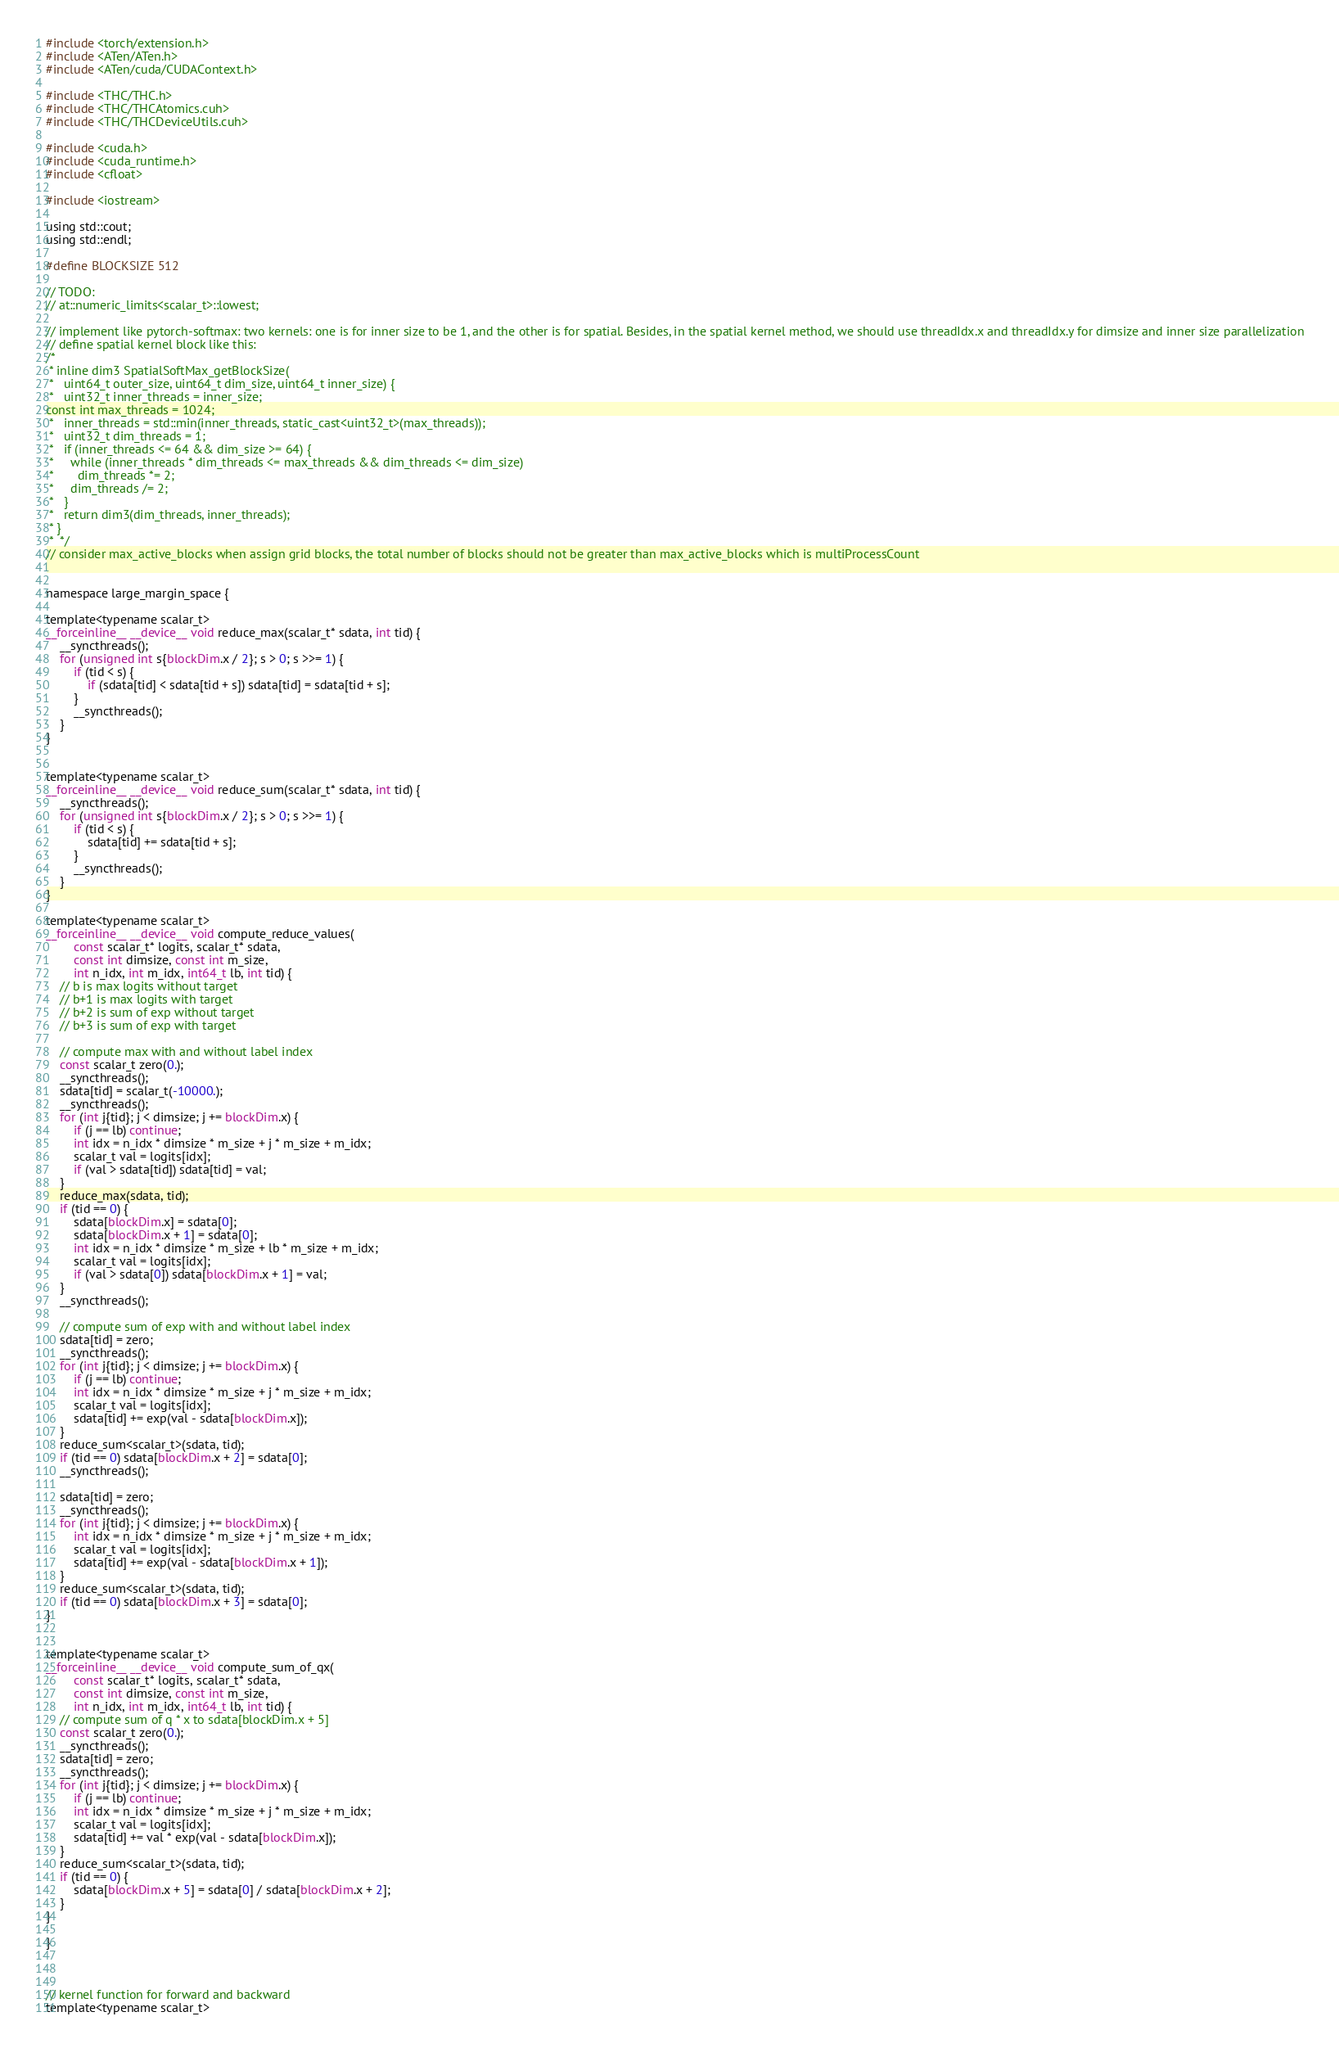Convert code to text. <code><loc_0><loc_0><loc_500><loc_500><_Cuda_>
#include <torch/extension.h>
#include <ATen/ATen.h>
#include <ATen/cuda/CUDAContext.h>

#include <THC/THC.h>
#include <THC/THCAtomics.cuh>
#include <THC/THCDeviceUtils.cuh>

#include <cuda.h>
#include <cuda_runtime.h>
#include <cfloat>

#include <iostream>

using std::cout;
using std::endl;

#define BLOCKSIZE 512

// TODO: 
// at::numeric_limits<scalar_t>::lowest;

// implement like pytorch-softmax: two kernels: one is for inner size to be 1, and the other is for spatial. Besides, in the spatial kernel method, we should use threadIdx.x and threadIdx.y for dimsize and inner size parallelization
// define spatial kernel block like this: 
/* 
 * inline dim3 SpatialSoftMax_getBlockSize(
 *   uint64_t outer_size, uint64_t dim_size, uint64_t inner_size) {
 *   uint32_t inner_threads = inner_size;
const int max_threads = 1024;
 *   inner_threads = std::min(inner_threads, static_cast<uint32_t>(max_threads));
 *   uint32_t dim_threads = 1;
 *   if (inner_threads <= 64 && dim_size >= 64) {
 *     while (inner_threads * dim_threads <= max_threads && dim_threads <= dim_size)
 *       dim_threads *= 2;
 *     dim_threads /= 2;
 *   }
 *   return dim3(dim_threads, inner_threads);
 * }
 *  */
// consider max_active_blocks when assign grid blocks, the total number of blocks should not be greater than max_active_blocks which is multiProcessCount


namespace large_margin_space {

template<typename scalar_t>
__forceinline__ __device__ void reduce_max(scalar_t* sdata, int tid) {
    __syncthreads();
    for (unsigned int s{blockDim.x / 2}; s > 0; s >>= 1) {
        if (tid < s) {
            if (sdata[tid] < sdata[tid + s]) sdata[tid] = sdata[tid + s];
        }
        __syncthreads();
    }
}


template<typename scalar_t>
__forceinline__ __device__ void reduce_sum(scalar_t* sdata, int tid) {
    __syncthreads();
    for (unsigned int s{blockDim.x / 2}; s > 0; s >>= 1) {
        if (tid < s) {
            sdata[tid] += sdata[tid + s];
        }
        __syncthreads();
    }
}

template<typename scalar_t>
__forceinline__ __device__ void compute_reduce_values(
        const scalar_t* logits, scalar_t* sdata,
        const int dimsize, const int m_size, 
        int n_idx, int m_idx, int64_t lb, int tid) {
    // b is max logits without target 
    // b+1 is max logits with target 
    // b+2 is sum of exp without target 
    // b+3 is sum of exp with target 

    // compute max with and without label index
    const scalar_t zero(0.);
    __syncthreads();
    sdata[tid] = scalar_t(-10000.);
    __syncthreads();
    for (int j{tid}; j < dimsize; j += blockDim.x) {
        if (j == lb) continue;
        int idx = n_idx * dimsize * m_size + j * m_size + m_idx;
        scalar_t val = logits[idx];
        if (val > sdata[tid]) sdata[tid] = val;
    }
    reduce_max(sdata, tid);
    if (tid == 0) {
        sdata[blockDim.x] = sdata[0];
        sdata[blockDim.x + 1] = sdata[0];
        int idx = n_idx * dimsize * m_size + lb * m_size + m_idx;
        scalar_t val = logits[idx];
        if (val > sdata[0]) sdata[blockDim.x + 1] = val;
    }
    __syncthreads();

    // compute sum of exp with and without label index
    sdata[tid] = zero;
    __syncthreads();
    for (int j{tid}; j < dimsize; j += blockDim.x) {
        if (j == lb) continue;
        int idx = n_idx * dimsize * m_size + j * m_size + m_idx;
        scalar_t val = logits[idx];
        sdata[tid] += exp(val - sdata[blockDim.x]);
    }
    reduce_sum<scalar_t>(sdata, tid);
    if (tid == 0) sdata[blockDim.x + 2] = sdata[0];
    __syncthreads();

    sdata[tid] = zero;
    __syncthreads();
    for (int j{tid}; j < dimsize; j += blockDim.x) {
        int idx = n_idx * dimsize * m_size + j * m_size + m_idx;
        scalar_t val = logits[idx];
        sdata[tid] += exp(val - sdata[blockDim.x + 1]);
    }
    reduce_sum<scalar_t>(sdata, tid);
    if (tid == 0) sdata[blockDim.x + 3] = sdata[0];
}


template<typename scalar_t>
__forceinline__ __device__ void compute_sum_of_qx(
        const scalar_t* logits, scalar_t* sdata,
        const int dimsize, const int m_size, 
        int n_idx, int m_idx, int64_t lb, int tid) {
    // compute sum of q * x to sdata[blockDim.x + 5]
    const scalar_t zero(0.);
    __syncthreads();
    sdata[tid] = zero;
    __syncthreads();
    for (int j{tid}; j < dimsize; j += blockDim.x) {
        if (j == lb) continue;
        int idx = n_idx * dimsize * m_size + j * m_size + m_idx; 
        scalar_t val = logits[idx];
        sdata[tid] += val * exp(val - sdata[blockDim.x]);
    }
    reduce_sum<scalar_t>(sdata, tid);
    if (tid == 0) {
        sdata[blockDim.x + 5] = sdata[0] / sdata[blockDim.x + 2]; 
    }
}

}



// kernel function for forward and backward
template<typename scalar_t></code> 